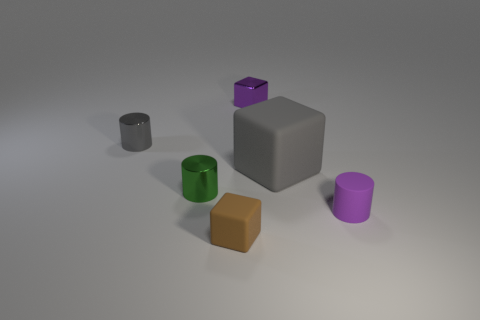Subtract all gray matte blocks. How many blocks are left? 2 Subtract all purple cylinders. How many cylinders are left? 2 Add 3 green shiny things. How many objects exist? 9 Subtract 1 cubes. How many cubes are left? 2 Subtract all large purple cylinders. Subtract all brown matte things. How many objects are left? 5 Add 1 large gray matte blocks. How many large gray matte blocks are left? 2 Add 5 brown matte objects. How many brown matte objects exist? 6 Subtract 1 gray blocks. How many objects are left? 5 Subtract all brown cylinders. Subtract all red cubes. How many cylinders are left? 3 